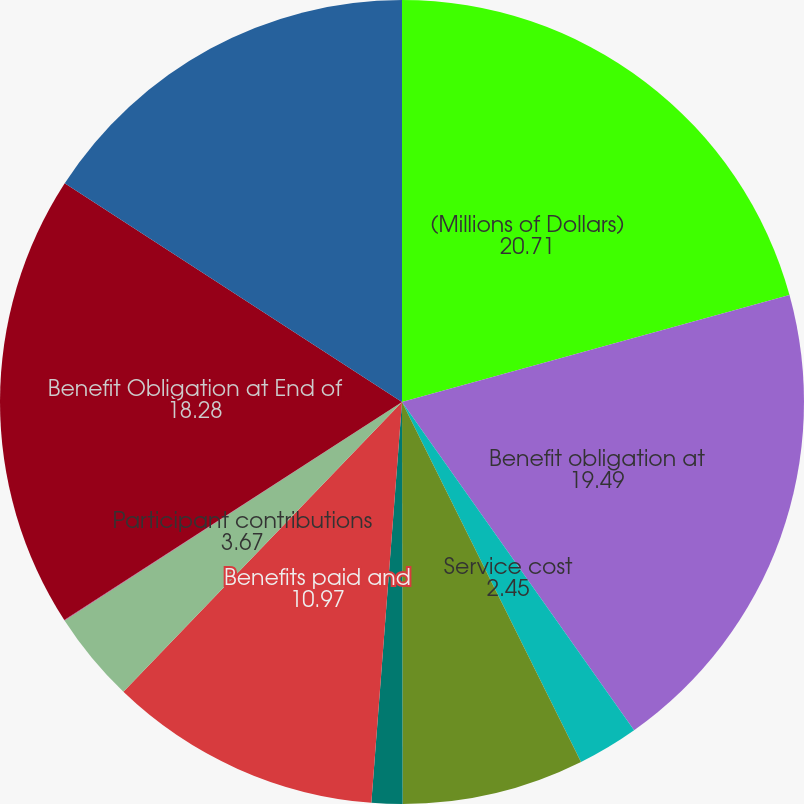Convert chart. <chart><loc_0><loc_0><loc_500><loc_500><pie_chart><fcel>(Millions of Dollars)<fcel>Benefit obligation at<fcel>Service cost<fcel>Interest cost on accumulated<fcel>Net actuarial loss/(gain)<fcel>Benefits paid and<fcel>Participant contributions<fcel>Medicare prescription benefit<fcel>Benefit Obligation at End of<fcel>Fair value of plan assets at<nl><fcel>20.71%<fcel>19.49%<fcel>2.45%<fcel>7.32%<fcel>1.24%<fcel>10.97%<fcel>3.67%<fcel>0.02%<fcel>18.28%<fcel>15.84%<nl></chart> 